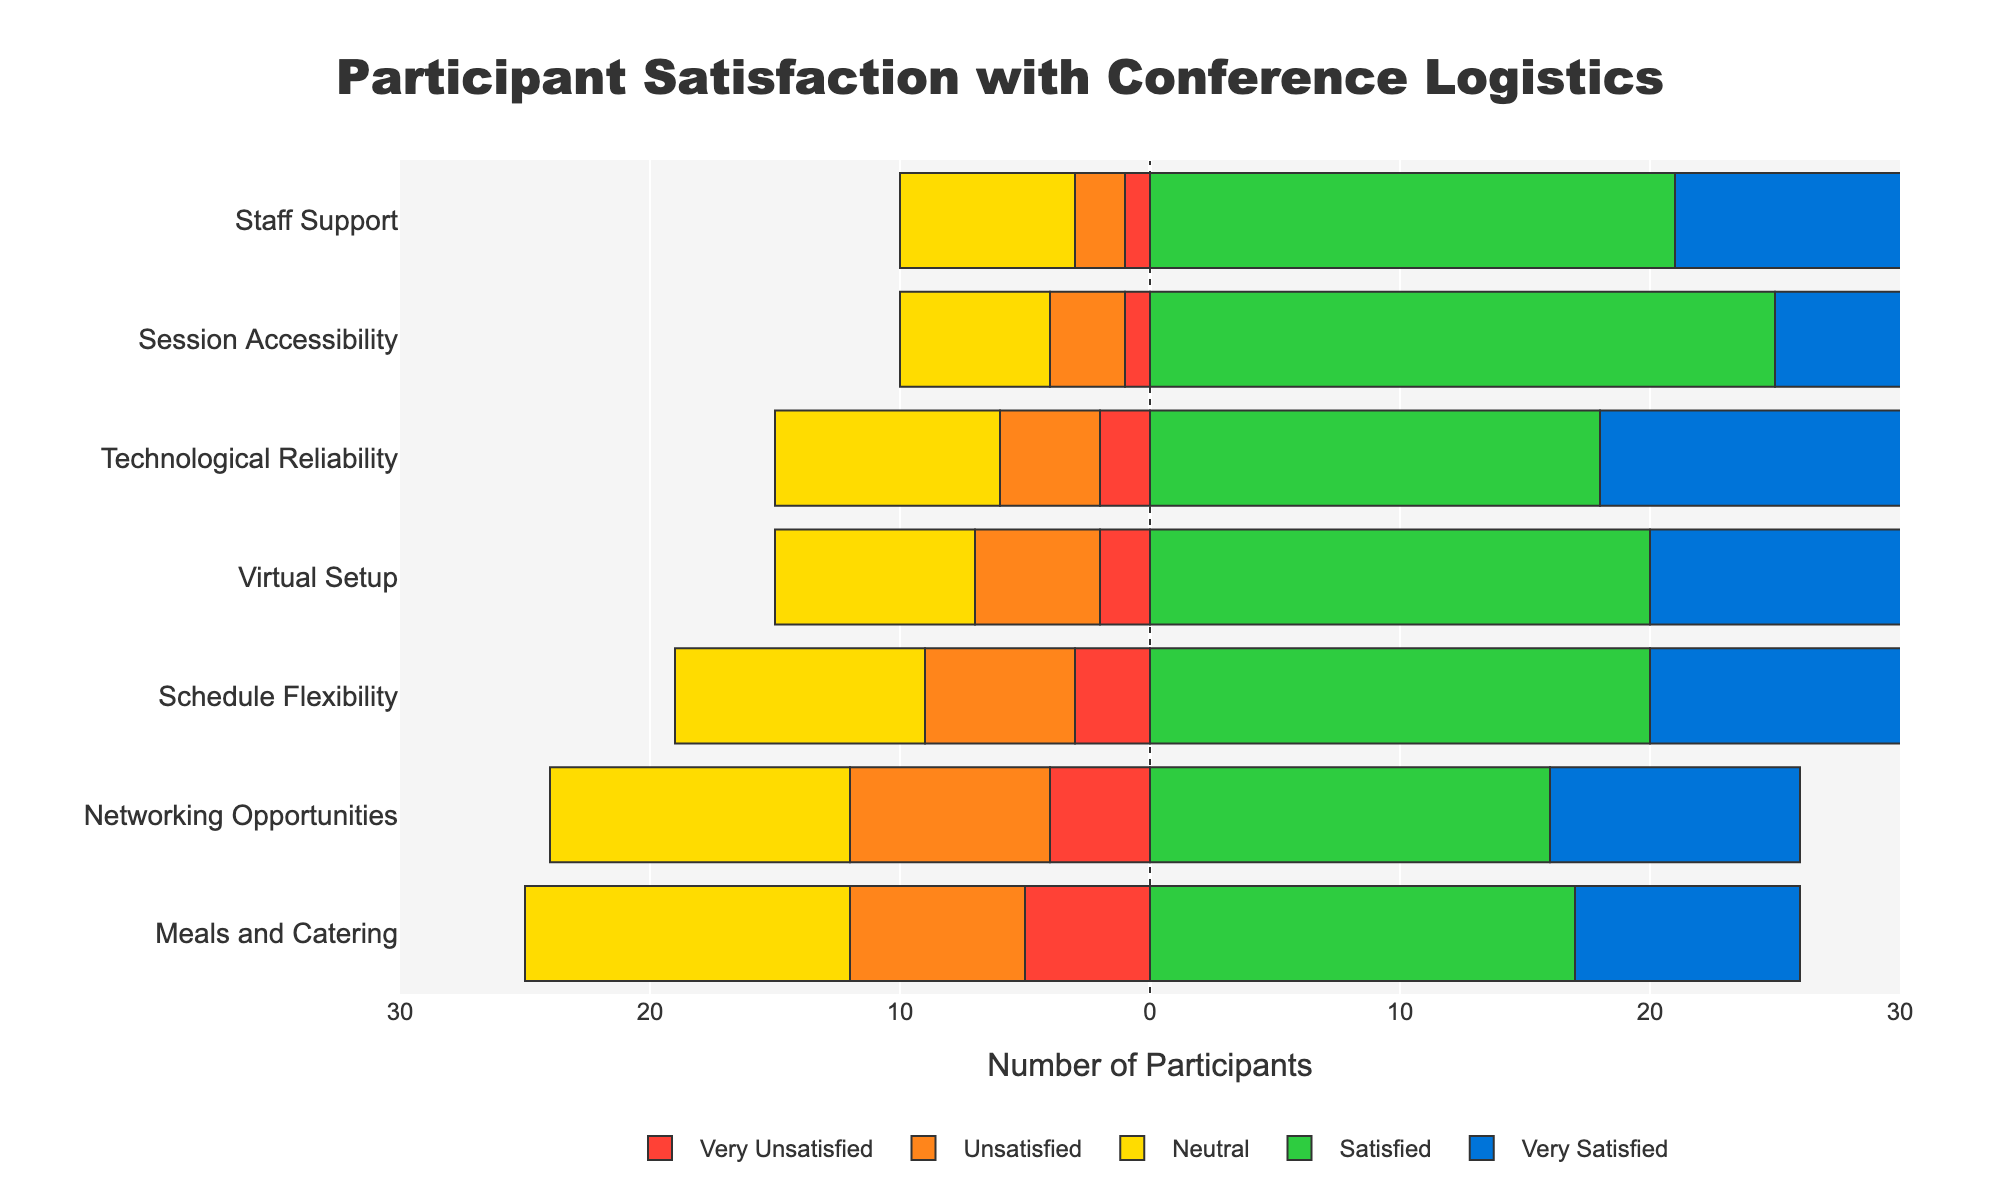What's the overall satisfaction for "Session Accessibility"? To determine the overall satisfaction, sum the values for "Satisfied" and "Very Satisfied". "Satisfied" is 25 and "Very Satisfied" is 15, giving us 25 + 15 = 40.
Answer: 40 Which logistic element has the highest number of "Very Unsatisfied" participants? Look for the highest value in the "Very Unsatisfied" column. "Meals and Catering" has the highest value with 5 participants.
Answer: Meals and Catering Compare the total satisfaction (Satisfied + Very Satisfied) of "Virtual Setup" and "Networking Opportunities". Which element is more satisfactory? For "Virtual Setup", "Satisfied" is 20 and "Very Satisfied" is 15, so 20 + 15 = 35. For "Networking Opportunities", "Satisfied" is 16 and "Very Satisfied" is 10, so 16 + 10 = 26. "Virtual Setup" has a higher total satisfaction.
Answer: Virtual Setup Which element has the most "Neutral" responses? Look for the highest value in the "Neutral" column. "Meals and Catering" has the highest value with 13 participants.
Answer: Meals and Catering What is the difference between the total "Unsatisfied" responses of "Schedule Flexibility" and "Technological Reliability"? For "Schedule Flexibility", the total number of "Unsatisfied" responses is 6. For "Technological Reliability", it's 4. The difference is 6 - 4 = 2.
Answer: 2 Which two elements have the closest total number of "Very Satisfied" participants? Compare the values in the "Very Satisfied" column: "Virtual Setup" (15), "Networking Opportunities" (10), "Session Accessibility" (15), "Schedule Flexibility" (11), "Technological Reliability" (18), "Staff Support" (20), and "Meals and Catering" (9). "Schedule Flexibility" (11) and "Meals and Catering" (9) are the closest with a difference of 11 - 9 = 2.
Answer: Schedule Flexibility and Meals and Catering What is the ratio of satisfied participants (Satisfied + Very Satisfied) to unsatisfied participants (Very Unsatisfied + Unsatisfied) for "Staff Support"? "Staff Support" has 21 "Satisfied" and 20 "Very Satisfied" participants, totaling 21 + 20 = 41 satisfied participants. It also has 1 "Very Unsatisfied" and 2 "Unsatisfied" participants, totaling 1 + 2 = 3 unsatisfied participants. The ratio is 41:3.
Answer: 41:3 How many more participants are "Very Satisfied" with "Technological Reliability" compared to "Networking Opportunities"? The number of "Very Satisfied" participants for "Technological Reliability" is 18. For "Networking Opportunities", it is 10. The difference is 18 - 10 = 8.
Answer: 8 What is the combined total of "Very Unsatisfied" and "Unsatisfied" participants across all elements? Sum the "Very Unsatisfied" and "Unsatisfied" columns' values: (2+4+1+3+2+1+5) + (5+8+3+6+4+2+7) = 18 + 35 = 53.
Answer: 53 